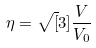<formula> <loc_0><loc_0><loc_500><loc_500>\eta = \sqrt { [ } 3 ] { \frac { V } { V _ { 0 } } }</formula> 